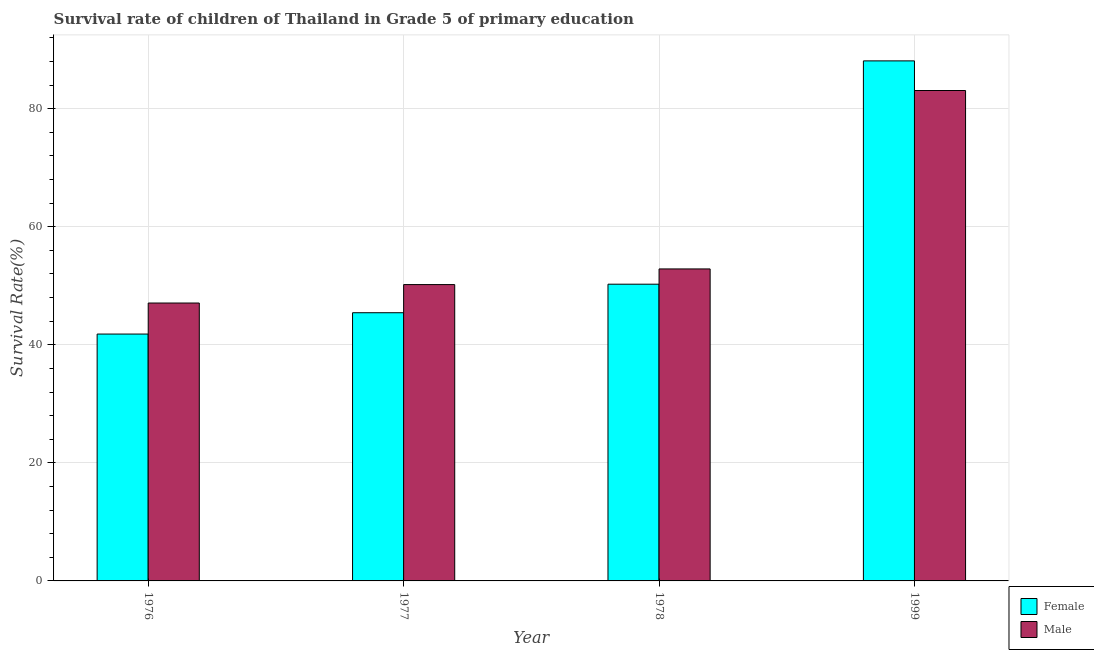How many groups of bars are there?
Provide a succinct answer. 4. Are the number of bars per tick equal to the number of legend labels?
Make the answer very short. Yes. How many bars are there on the 3rd tick from the right?
Offer a very short reply. 2. What is the label of the 2nd group of bars from the left?
Make the answer very short. 1977. What is the survival rate of male students in primary education in 1999?
Provide a succinct answer. 83.08. Across all years, what is the maximum survival rate of male students in primary education?
Ensure brevity in your answer.  83.08. Across all years, what is the minimum survival rate of male students in primary education?
Your answer should be compact. 47.08. In which year was the survival rate of male students in primary education minimum?
Make the answer very short. 1976. What is the total survival rate of female students in primary education in the graph?
Your answer should be compact. 225.63. What is the difference between the survival rate of male students in primary education in 1978 and that in 1999?
Give a very brief answer. -30.23. What is the difference between the survival rate of female students in primary education in 1977 and the survival rate of male students in primary education in 1999?
Give a very brief answer. -42.67. What is the average survival rate of male students in primary education per year?
Your response must be concise. 58.31. What is the ratio of the survival rate of male students in primary education in 1977 to that in 1978?
Offer a terse response. 0.95. What is the difference between the highest and the second highest survival rate of female students in primary education?
Provide a short and direct response. 37.83. What is the difference between the highest and the lowest survival rate of male students in primary education?
Your answer should be very brief. 36. Is the sum of the survival rate of male students in primary education in 1978 and 1999 greater than the maximum survival rate of female students in primary education across all years?
Your response must be concise. Yes. What does the 2nd bar from the left in 1978 represents?
Your answer should be very brief. Male. Are all the bars in the graph horizontal?
Keep it short and to the point. No. How many years are there in the graph?
Offer a very short reply. 4. Does the graph contain any zero values?
Provide a short and direct response. No. Does the graph contain grids?
Ensure brevity in your answer.  Yes. Where does the legend appear in the graph?
Ensure brevity in your answer.  Bottom right. How are the legend labels stacked?
Keep it short and to the point. Vertical. What is the title of the graph?
Provide a succinct answer. Survival rate of children of Thailand in Grade 5 of primary education. What is the label or title of the Y-axis?
Offer a very short reply. Survival Rate(%). What is the Survival Rate(%) of Female in 1976?
Your response must be concise. 41.82. What is the Survival Rate(%) of Male in 1976?
Offer a terse response. 47.08. What is the Survival Rate(%) in Female in 1977?
Ensure brevity in your answer.  45.44. What is the Survival Rate(%) of Male in 1977?
Provide a short and direct response. 50.2. What is the Survival Rate(%) in Female in 1978?
Your answer should be very brief. 50.27. What is the Survival Rate(%) in Male in 1978?
Your answer should be very brief. 52.86. What is the Survival Rate(%) in Female in 1999?
Provide a succinct answer. 88.1. What is the Survival Rate(%) of Male in 1999?
Make the answer very short. 83.08. Across all years, what is the maximum Survival Rate(%) in Female?
Provide a short and direct response. 88.1. Across all years, what is the maximum Survival Rate(%) in Male?
Give a very brief answer. 83.08. Across all years, what is the minimum Survival Rate(%) of Female?
Give a very brief answer. 41.82. Across all years, what is the minimum Survival Rate(%) of Male?
Your response must be concise. 47.08. What is the total Survival Rate(%) in Female in the graph?
Your response must be concise. 225.63. What is the total Survival Rate(%) of Male in the graph?
Ensure brevity in your answer.  233.22. What is the difference between the Survival Rate(%) of Female in 1976 and that in 1977?
Offer a terse response. -3.61. What is the difference between the Survival Rate(%) of Male in 1976 and that in 1977?
Provide a succinct answer. -3.12. What is the difference between the Survival Rate(%) of Female in 1976 and that in 1978?
Offer a terse response. -8.45. What is the difference between the Survival Rate(%) of Male in 1976 and that in 1978?
Make the answer very short. -5.78. What is the difference between the Survival Rate(%) in Female in 1976 and that in 1999?
Your answer should be very brief. -46.28. What is the difference between the Survival Rate(%) of Male in 1976 and that in 1999?
Give a very brief answer. -36. What is the difference between the Survival Rate(%) in Female in 1977 and that in 1978?
Your answer should be very brief. -4.83. What is the difference between the Survival Rate(%) in Male in 1977 and that in 1978?
Offer a very short reply. -2.65. What is the difference between the Survival Rate(%) in Female in 1977 and that in 1999?
Ensure brevity in your answer.  -42.67. What is the difference between the Survival Rate(%) in Male in 1977 and that in 1999?
Give a very brief answer. -32.88. What is the difference between the Survival Rate(%) in Female in 1978 and that in 1999?
Your answer should be compact. -37.83. What is the difference between the Survival Rate(%) in Male in 1978 and that in 1999?
Your response must be concise. -30.23. What is the difference between the Survival Rate(%) in Female in 1976 and the Survival Rate(%) in Male in 1977?
Keep it short and to the point. -8.38. What is the difference between the Survival Rate(%) in Female in 1976 and the Survival Rate(%) in Male in 1978?
Give a very brief answer. -11.03. What is the difference between the Survival Rate(%) of Female in 1976 and the Survival Rate(%) of Male in 1999?
Give a very brief answer. -41.26. What is the difference between the Survival Rate(%) of Female in 1977 and the Survival Rate(%) of Male in 1978?
Your response must be concise. -7.42. What is the difference between the Survival Rate(%) of Female in 1977 and the Survival Rate(%) of Male in 1999?
Offer a very short reply. -37.65. What is the difference between the Survival Rate(%) of Female in 1978 and the Survival Rate(%) of Male in 1999?
Give a very brief answer. -32.81. What is the average Survival Rate(%) of Female per year?
Ensure brevity in your answer.  56.41. What is the average Survival Rate(%) in Male per year?
Give a very brief answer. 58.31. In the year 1976, what is the difference between the Survival Rate(%) in Female and Survival Rate(%) in Male?
Keep it short and to the point. -5.26. In the year 1977, what is the difference between the Survival Rate(%) of Female and Survival Rate(%) of Male?
Keep it short and to the point. -4.77. In the year 1978, what is the difference between the Survival Rate(%) of Female and Survival Rate(%) of Male?
Your answer should be compact. -2.59. In the year 1999, what is the difference between the Survival Rate(%) of Female and Survival Rate(%) of Male?
Keep it short and to the point. 5.02. What is the ratio of the Survival Rate(%) of Female in 1976 to that in 1977?
Make the answer very short. 0.92. What is the ratio of the Survival Rate(%) in Male in 1976 to that in 1977?
Offer a terse response. 0.94. What is the ratio of the Survival Rate(%) in Female in 1976 to that in 1978?
Provide a succinct answer. 0.83. What is the ratio of the Survival Rate(%) in Male in 1976 to that in 1978?
Offer a very short reply. 0.89. What is the ratio of the Survival Rate(%) of Female in 1976 to that in 1999?
Provide a short and direct response. 0.47. What is the ratio of the Survival Rate(%) in Male in 1976 to that in 1999?
Your response must be concise. 0.57. What is the ratio of the Survival Rate(%) of Female in 1977 to that in 1978?
Offer a very short reply. 0.9. What is the ratio of the Survival Rate(%) in Male in 1977 to that in 1978?
Your answer should be very brief. 0.95. What is the ratio of the Survival Rate(%) of Female in 1977 to that in 1999?
Offer a very short reply. 0.52. What is the ratio of the Survival Rate(%) in Male in 1977 to that in 1999?
Ensure brevity in your answer.  0.6. What is the ratio of the Survival Rate(%) in Female in 1978 to that in 1999?
Offer a very short reply. 0.57. What is the ratio of the Survival Rate(%) of Male in 1978 to that in 1999?
Your response must be concise. 0.64. What is the difference between the highest and the second highest Survival Rate(%) of Female?
Your answer should be compact. 37.83. What is the difference between the highest and the second highest Survival Rate(%) in Male?
Give a very brief answer. 30.23. What is the difference between the highest and the lowest Survival Rate(%) of Female?
Your answer should be compact. 46.28. What is the difference between the highest and the lowest Survival Rate(%) in Male?
Your answer should be compact. 36. 